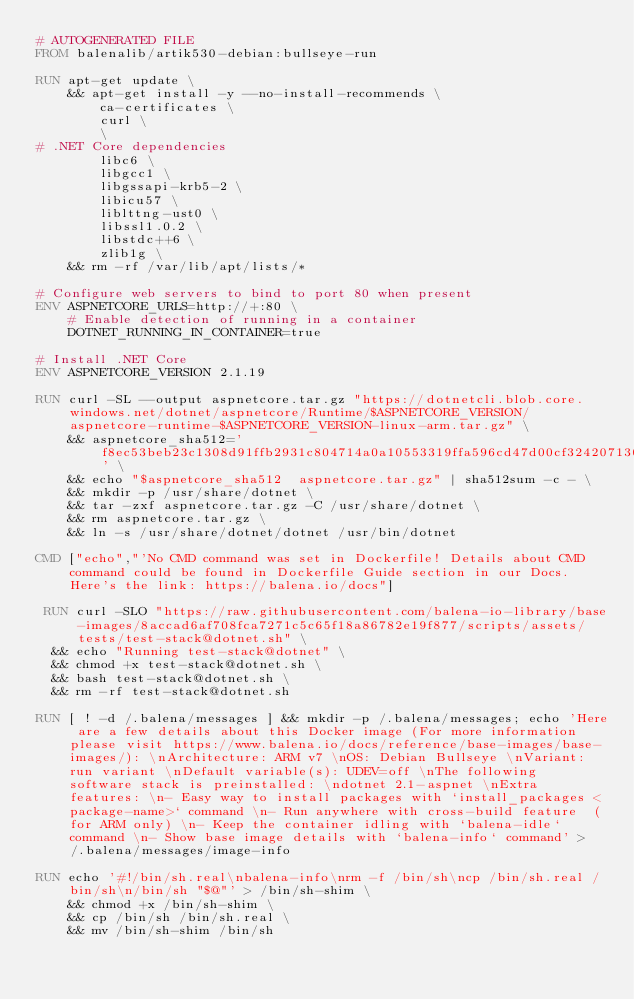Convert code to text. <code><loc_0><loc_0><loc_500><loc_500><_Dockerfile_># AUTOGENERATED FILE
FROM balenalib/artik530-debian:bullseye-run

RUN apt-get update \
    && apt-get install -y --no-install-recommends \
        ca-certificates \
        curl \
        \
# .NET Core dependencies
        libc6 \
        libgcc1 \
        libgssapi-krb5-2 \
        libicu57 \
        liblttng-ust0 \
        libssl1.0.2 \
        libstdc++6 \
        zlib1g \
    && rm -rf /var/lib/apt/lists/*

# Configure web servers to bind to port 80 when present
ENV ASPNETCORE_URLS=http://+:80 \
    # Enable detection of running in a container
    DOTNET_RUNNING_IN_CONTAINER=true

# Install .NET Core
ENV ASPNETCORE_VERSION 2.1.19

RUN curl -SL --output aspnetcore.tar.gz "https://dotnetcli.blob.core.windows.net/dotnet/aspnetcore/Runtime/$ASPNETCORE_VERSION/aspnetcore-runtime-$ASPNETCORE_VERSION-linux-arm.tar.gz" \
    && aspnetcore_sha512='f8ec53beb23c1308d91ffb2931c804714a0a10553319ffa596cd47d00cf324207130397f90ab5b78dc3d4f408eefd6753221254abaf0d02ffca9522b85851892' \
    && echo "$aspnetcore_sha512  aspnetcore.tar.gz" | sha512sum -c - \
    && mkdir -p /usr/share/dotnet \
    && tar -zxf aspnetcore.tar.gz -C /usr/share/dotnet \
    && rm aspnetcore.tar.gz \
    && ln -s /usr/share/dotnet/dotnet /usr/bin/dotnet

CMD ["echo","'No CMD command was set in Dockerfile! Details about CMD command could be found in Dockerfile Guide section in our Docs. Here's the link: https://balena.io/docs"]

 RUN curl -SLO "https://raw.githubusercontent.com/balena-io-library/base-images/8accad6af708fca7271c5c65f18a86782e19f877/scripts/assets/tests/test-stack@dotnet.sh" \
  && echo "Running test-stack@dotnet" \
  && chmod +x test-stack@dotnet.sh \
  && bash test-stack@dotnet.sh \
  && rm -rf test-stack@dotnet.sh 

RUN [ ! -d /.balena/messages ] && mkdir -p /.balena/messages; echo 'Here are a few details about this Docker image (For more information please visit https://www.balena.io/docs/reference/base-images/base-images/): \nArchitecture: ARM v7 \nOS: Debian Bullseye \nVariant: run variant \nDefault variable(s): UDEV=off \nThe following software stack is preinstalled: \ndotnet 2.1-aspnet \nExtra features: \n- Easy way to install packages with `install_packages <package-name>` command \n- Run anywhere with cross-build feature  (for ARM only) \n- Keep the container idling with `balena-idle` command \n- Show base image details with `balena-info` command' > /.balena/messages/image-info

RUN echo '#!/bin/sh.real\nbalena-info\nrm -f /bin/sh\ncp /bin/sh.real /bin/sh\n/bin/sh "$@"' > /bin/sh-shim \
	&& chmod +x /bin/sh-shim \
	&& cp /bin/sh /bin/sh.real \
	&& mv /bin/sh-shim /bin/sh</code> 